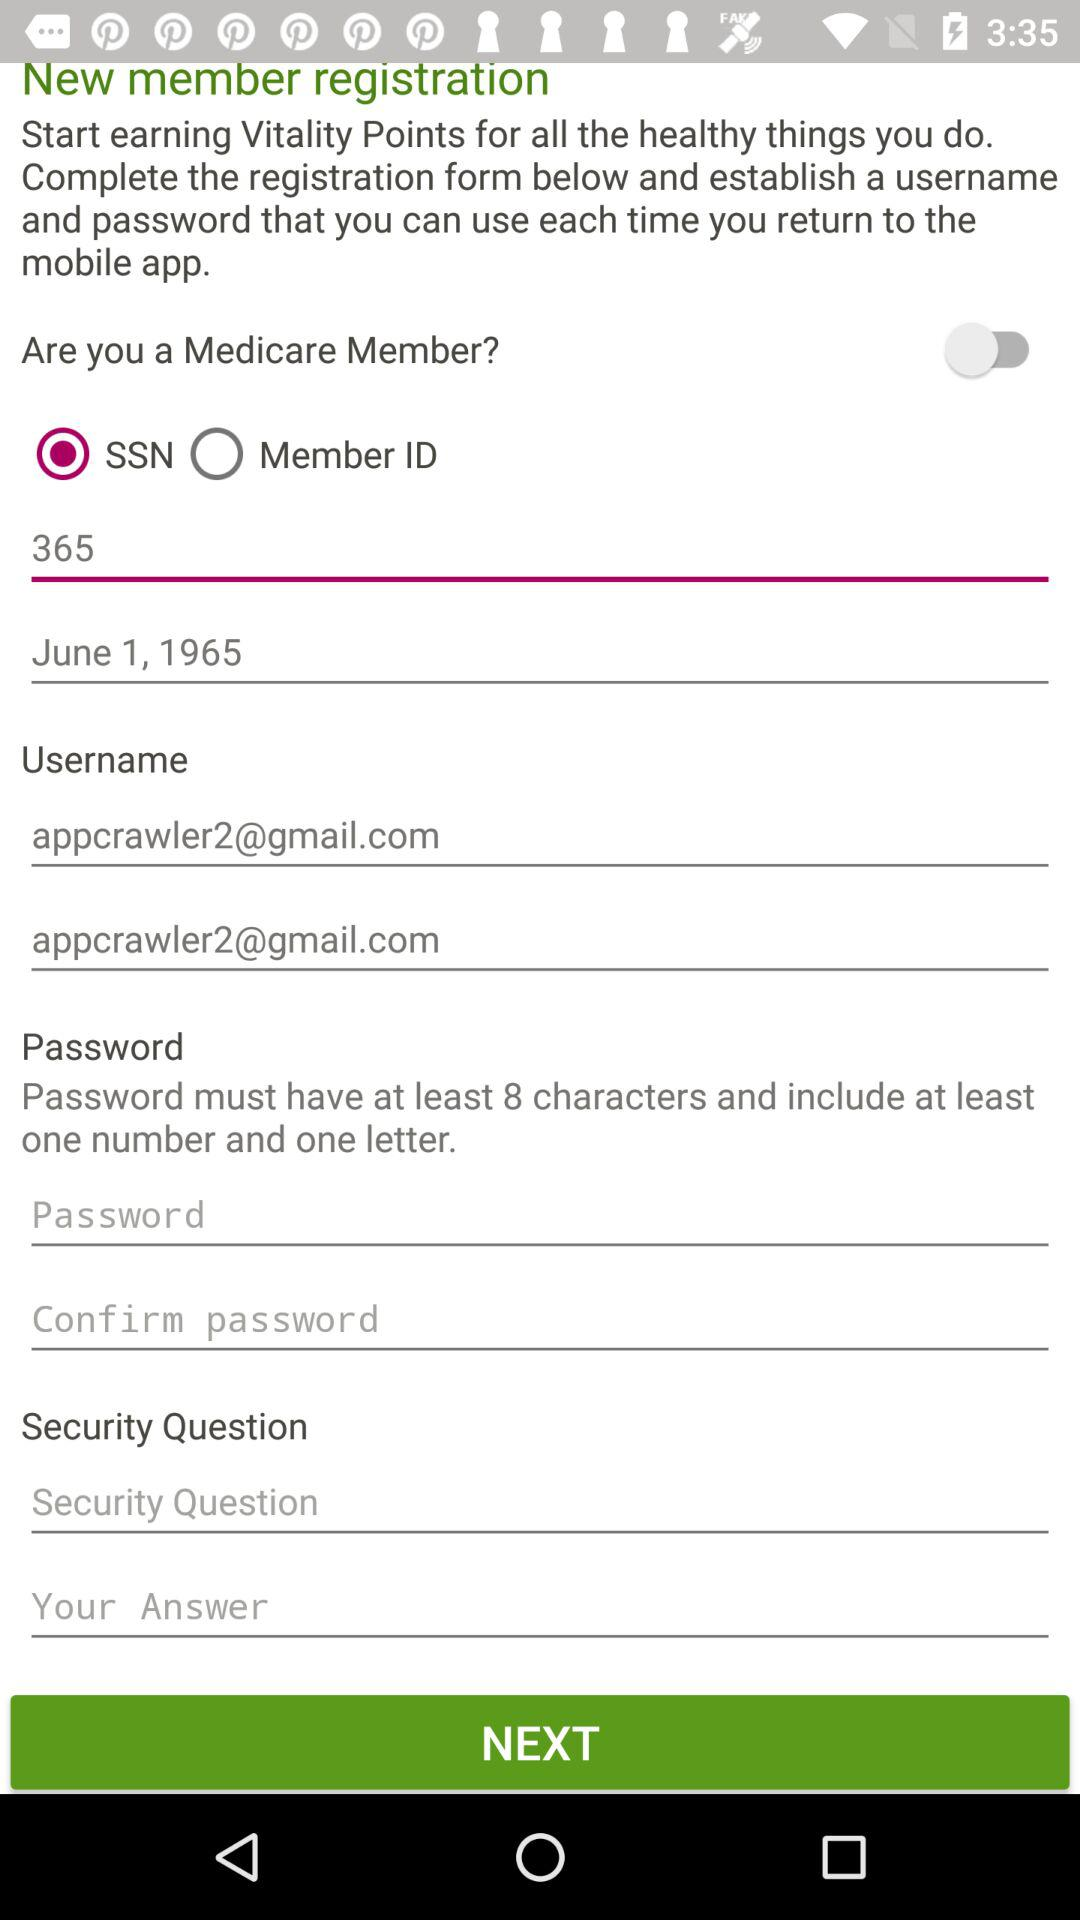How many minimum characters are required in the password? There are at least 8 characters required in the password. 